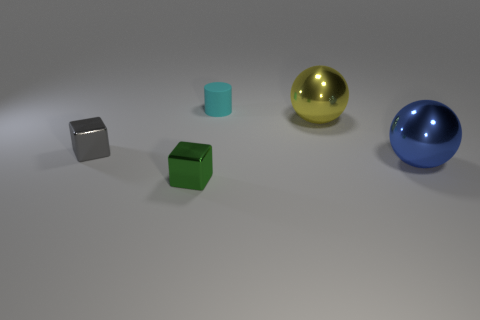Add 4 large balls. How many objects exist? 9 Subtract all cubes. How many objects are left? 3 Subtract all yellow cylinders. Subtract all yellow spheres. How many cylinders are left? 1 Subtract all big yellow balls. Subtract all purple things. How many objects are left? 4 Add 5 blue balls. How many blue balls are left? 6 Add 2 tiny shiny things. How many tiny shiny things exist? 4 Subtract 0 purple cylinders. How many objects are left? 5 